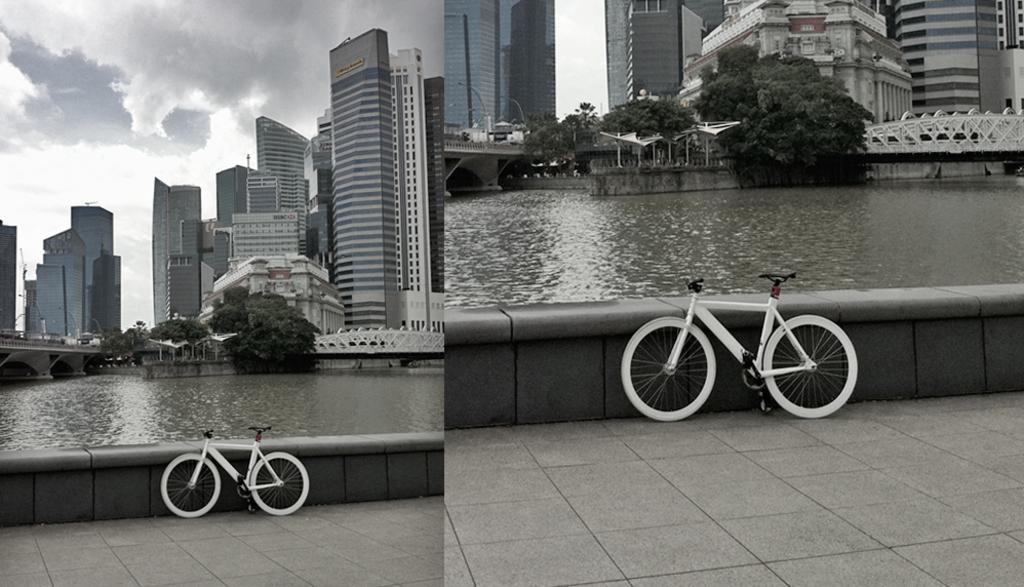What type of artwork is the image? The image is a collage. What mode of transportation can be seen in the image? There are bicycles in the image. What part of the environment is visible in the image? The floor is visible in the image. What architectural features are present in the image? There are walls, bridges, and buildings in the image. What type of vegetation is visible in the image? Trees are visible in the image. What part of the natural environment is visible in the image? The sky is visible in the image, and clouds are present in the sky. What type of holiday is being celebrated in the image? There is no indication of a holiday being celebrated in the image. How many houses are visible in the image? There are no houses present in the image; instead, there are buildings. What type of war is depicted in the image? There is no war depicted in the image; it is a collage featuring various elements and objects. 